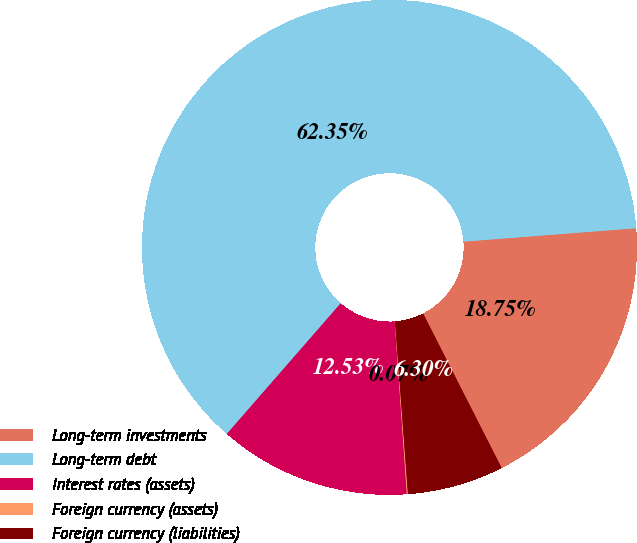Convert chart to OTSL. <chart><loc_0><loc_0><loc_500><loc_500><pie_chart><fcel>Long-term investments<fcel>Long-term debt<fcel>Interest rates (assets)<fcel>Foreign currency (assets)<fcel>Foreign currency (liabilities)<nl><fcel>18.75%<fcel>62.36%<fcel>12.53%<fcel>0.07%<fcel>6.3%<nl></chart> 